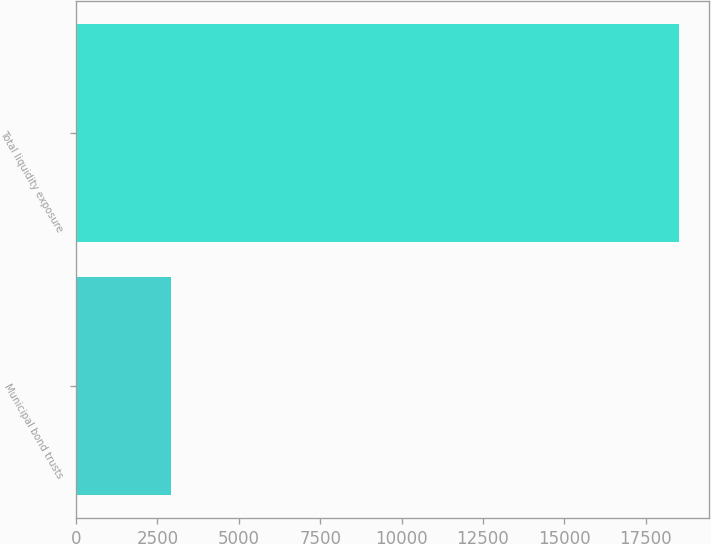Convert chart to OTSL. <chart><loc_0><loc_0><loc_500><loc_500><bar_chart><fcel>Municipal bond trusts<fcel>Total liquidity exposure<nl><fcel>2921<fcel>18509<nl></chart> 